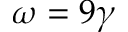<formula> <loc_0><loc_0><loc_500><loc_500>\omega = 9 \gamma</formula> 